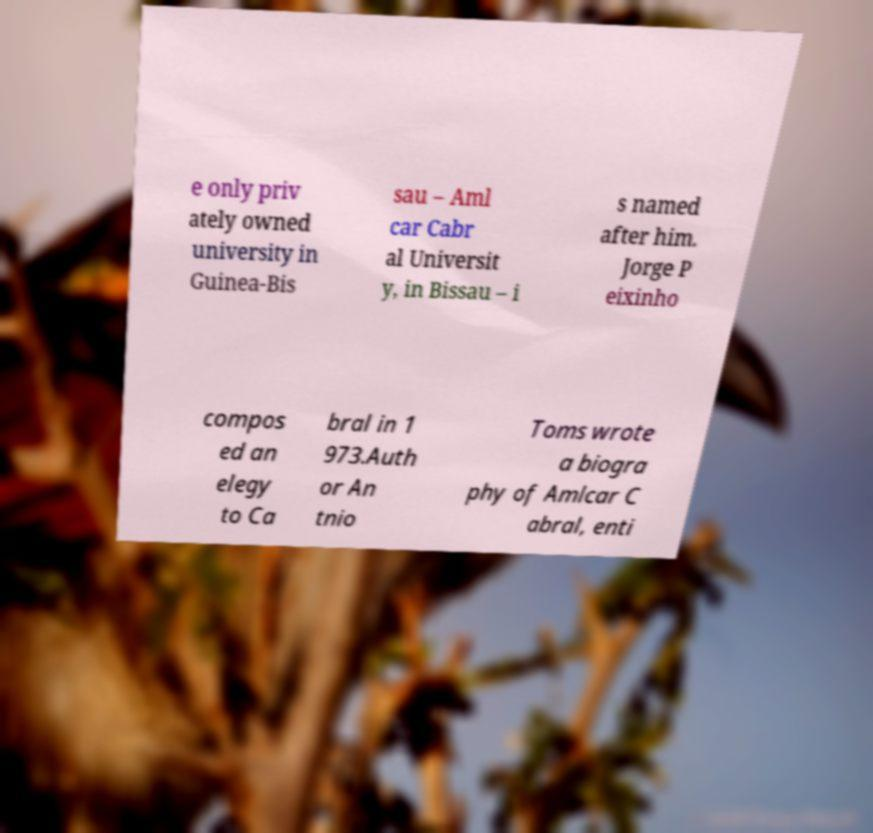What messages or text are displayed in this image? I need them in a readable, typed format. e only priv ately owned university in Guinea-Bis sau – Aml car Cabr al Universit y, in Bissau – i s named after him. Jorge P eixinho compos ed an elegy to Ca bral in 1 973.Auth or An tnio Toms wrote a biogra phy of Amlcar C abral, enti 